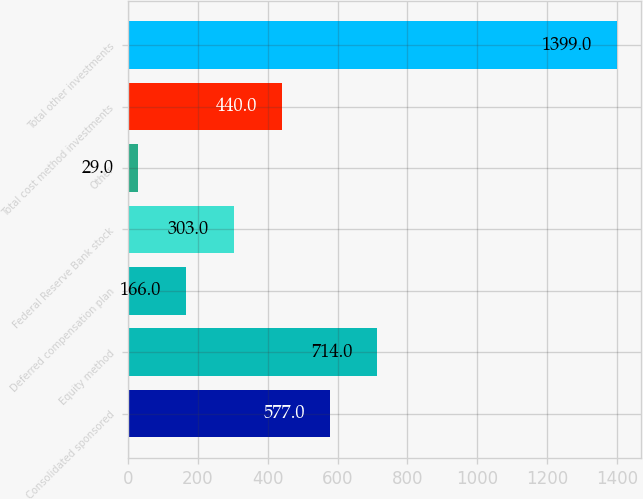<chart> <loc_0><loc_0><loc_500><loc_500><bar_chart><fcel>Consolidated sponsored<fcel>Equity method<fcel>Deferred compensation plan<fcel>Federal Reserve Bank stock<fcel>Other<fcel>Total cost method investments<fcel>Total other investments<nl><fcel>577<fcel>714<fcel>166<fcel>303<fcel>29<fcel>440<fcel>1399<nl></chart> 